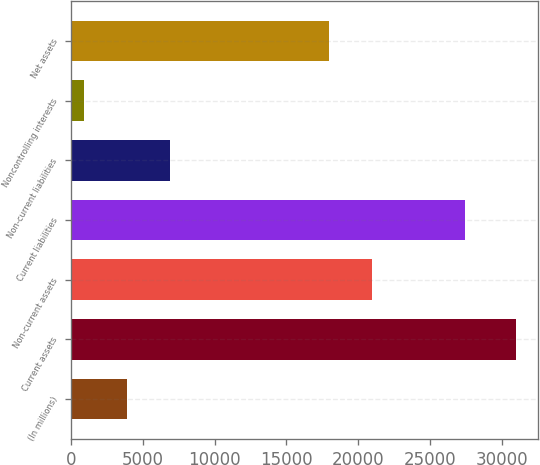<chart> <loc_0><loc_0><loc_500><loc_500><bar_chart><fcel>(In millions)<fcel>Current assets<fcel>Non-current assets<fcel>Current liabilities<fcel>Non-current liabilities<fcel>Noncontrolling interests<fcel>Net assets<nl><fcel>3897.6<fcel>30966<fcel>20991.6<fcel>27423<fcel>6905.2<fcel>890<fcel>17984<nl></chart> 